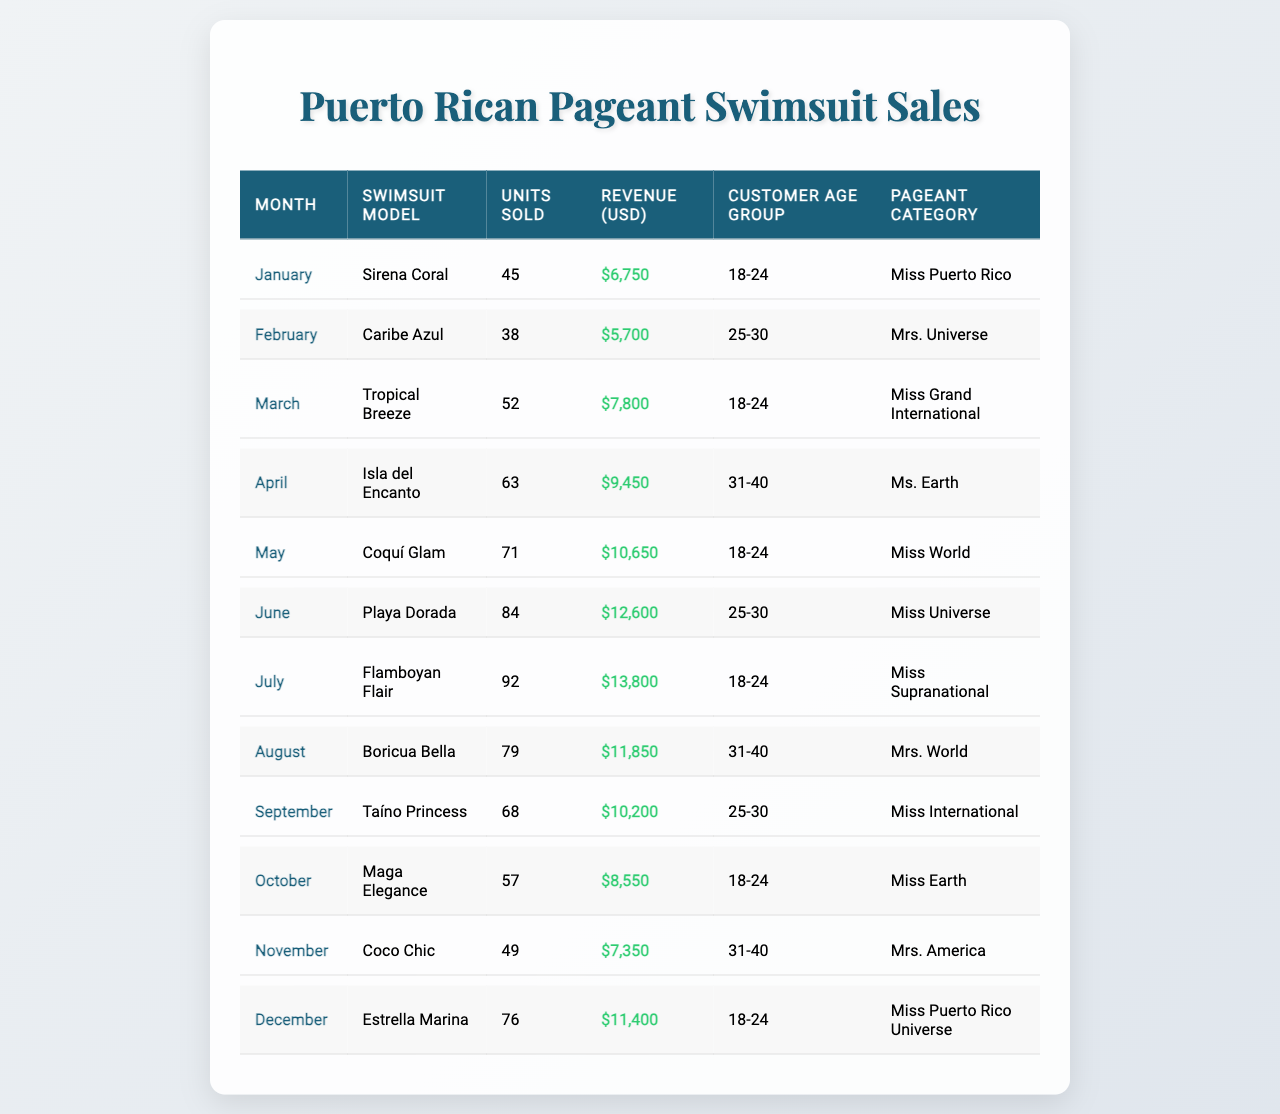What is the total revenue generated from swimsuit sales in June? The revenue for June is listed in the table, and it shows $12,600. Therefore, the total revenue generated from swimsuit sales in June is that amount.
Answer: $12,600 Which swimsuit model sold the most units in July? Referring to the table, the swimsuit model "Flamboyan Flair" which is listed for July shows 92 units sold, making it the highest for that month.
Answer: Flamboyan Flair How many swimsuits were sold in the month of December? Looking at the table, the column for December shows "76" units sold. Thus, this is the total number of swimsuits sold in that month.
Answer: 76 What is the average revenue generated per month over the year? To find the average revenue, we total all the revenues from each month: 6,750 + 5,700 + 7,800 + 9,450 + 10,650 + 12,600 + 13,800 + 11,850 + 10,200 + 8,550 + 7,350 + 11,400 = 119,200. Then, we divide that sum by the number of months (12), which is 119,200/12 = 9,933.33.
Answer: $9,933.33 Did more swimsuits sell in August than in October? By examining the units sold for August (79) and October (57) in the table, we see that August had a higher number sold. So, the answer is yes.
Answer: Yes What percentage of total sales in May were from the "Miss World" category? The total sales from all categories can be calculated by summing all units sold: 45 + 38 + 52 + 63 + 71 + 84 + 92 + 79 + 68 + 57 + 49 + 76 = 792. In May, "Coquí Glam" represents 71 units, leading to a percentage of (71/792) * 100 = 8.96%.
Answer: 8.96% Which age group purchased the most swimsuits in June? The table shows that in June, the age group of "25-30" is associated with the swimsuit model "Playa Dorada" with 84 units sold, which is the highest in that month. Thus, this age group sold the most swimsuits that month.
Answer: 25-30 Is it true that "Coco Chic" was sold in a month with sales exceeding $7,500? By checking the table for the month of November, "Coco Chic" shows $7,350 in revenue, which does not exceed $7,500. Therefore, it is false.
Answer: No What was the total number of units sold for the "Miss International" category? Looking at the table, "Taíno Princess" for September corresponds to the "Miss International" category with 68 units sold, giving us the total for that category.
Answer: 68 Which swimsuit model had the least revenue, and what was the amount? The model with the least revenue is "Caribe Azul" with revenue of $5,700, which is the lowest in the table.
Answer: Caribe Azul, $5,700 How many swimsuit models sold to customers aged 31-40? In the table, there are two entries for the age group "31-40": "Isla del Encanto" in April and "Boricua Bella" in August. This totals to two swimsuit models for this age group.
Answer: 2 